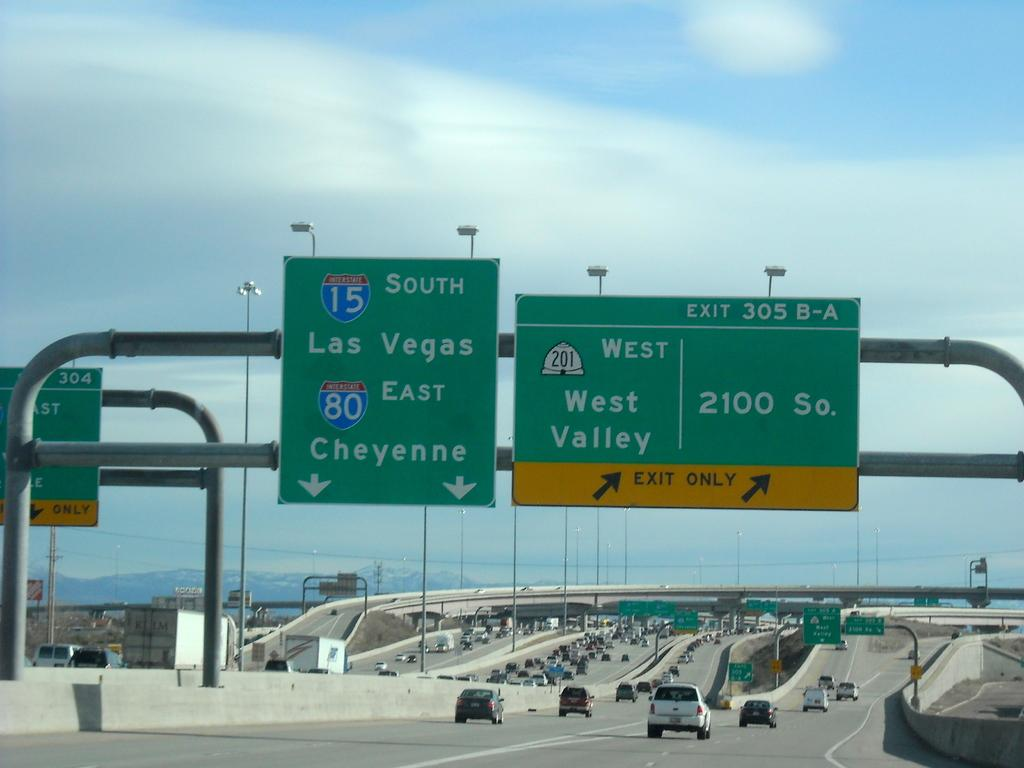Provide a one-sentence caption for the provided image. A green sign with lanes that go to 15 South Las Vegas and 80 East Cheyenne. 